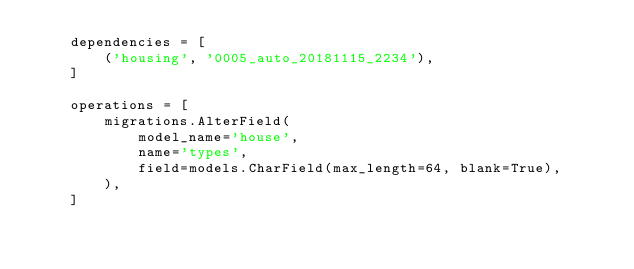Convert code to text. <code><loc_0><loc_0><loc_500><loc_500><_Python_>    dependencies = [
        ('housing', '0005_auto_20181115_2234'),
    ]

    operations = [
        migrations.AlterField(
            model_name='house',
            name='types',
            field=models.CharField(max_length=64, blank=True),
        ),
    ]
</code> 